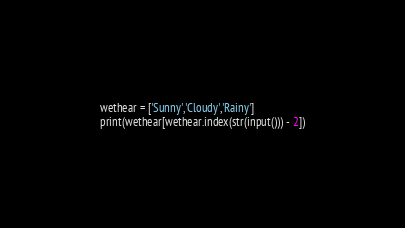<code> <loc_0><loc_0><loc_500><loc_500><_Python_>wethear = ['Sunny','Cloudy','Rainy']
print(wethear[wethear.index(str(input())) - 2])</code> 